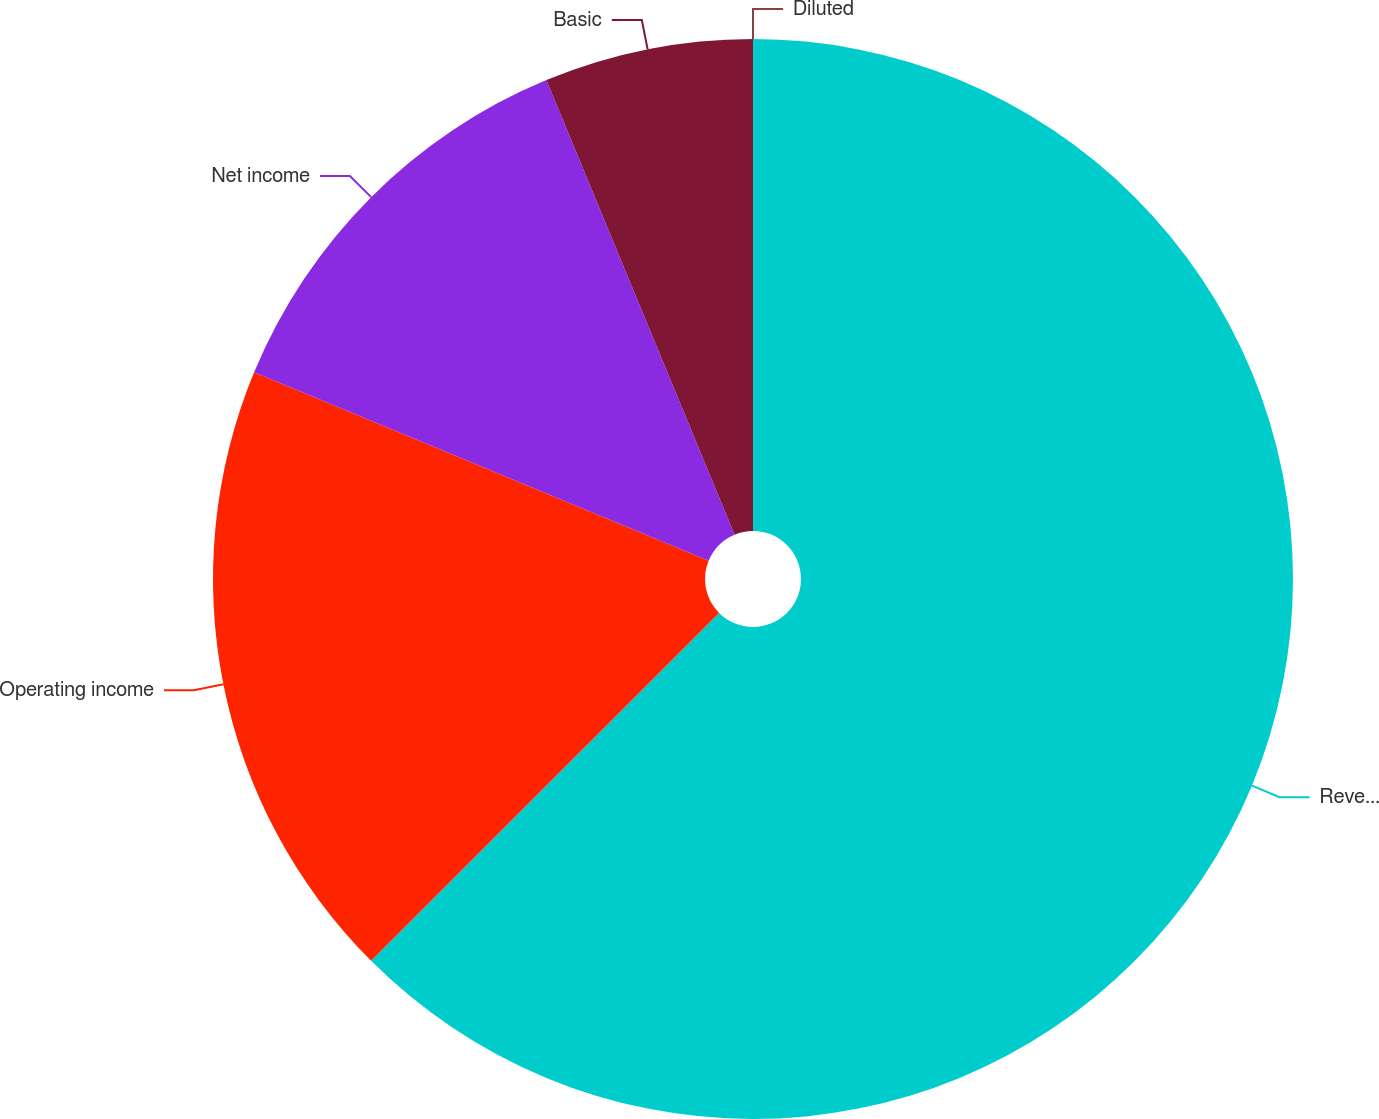Convert chart. <chart><loc_0><loc_0><loc_500><loc_500><pie_chart><fcel>Revenues<fcel>Operating income<fcel>Net income<fcel>Basic<fcel>Diluted<nl><fcel>62.5%<fcel>18.75%<fcel>12.5%<fcel>6.25%<fcel>0.0%<nl></chart> 